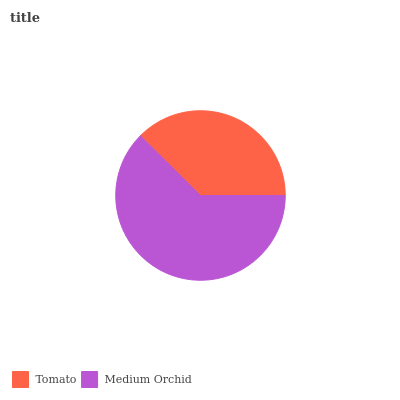Is Tomato the minimum?
Answer yes or no. Yes. Is Medium Orchid the maximum?
Answer yes or no. Yes. Is Medium Orchid the minimum?
Answer yes or no. No. Is Medium Orchid greater than Tomato?
Answer yes or no. Yes. Is Tomato less than Medium Orchid?
Answer yes or no. Yes. Is Tomato greater than Medium Orchid?
Answer yes or no. No. Is Medium Orchid less than Tomato?
Answer yes or no. No. Is Medium Orchid the high median?
Answer yes or no. Yes. Is Tomato the low median?
Answer yes or no. Yes. Is Tomato the high median?
Answer yes or no. No. Is Medium Orchid the low median?
Answer yes or no. No. 